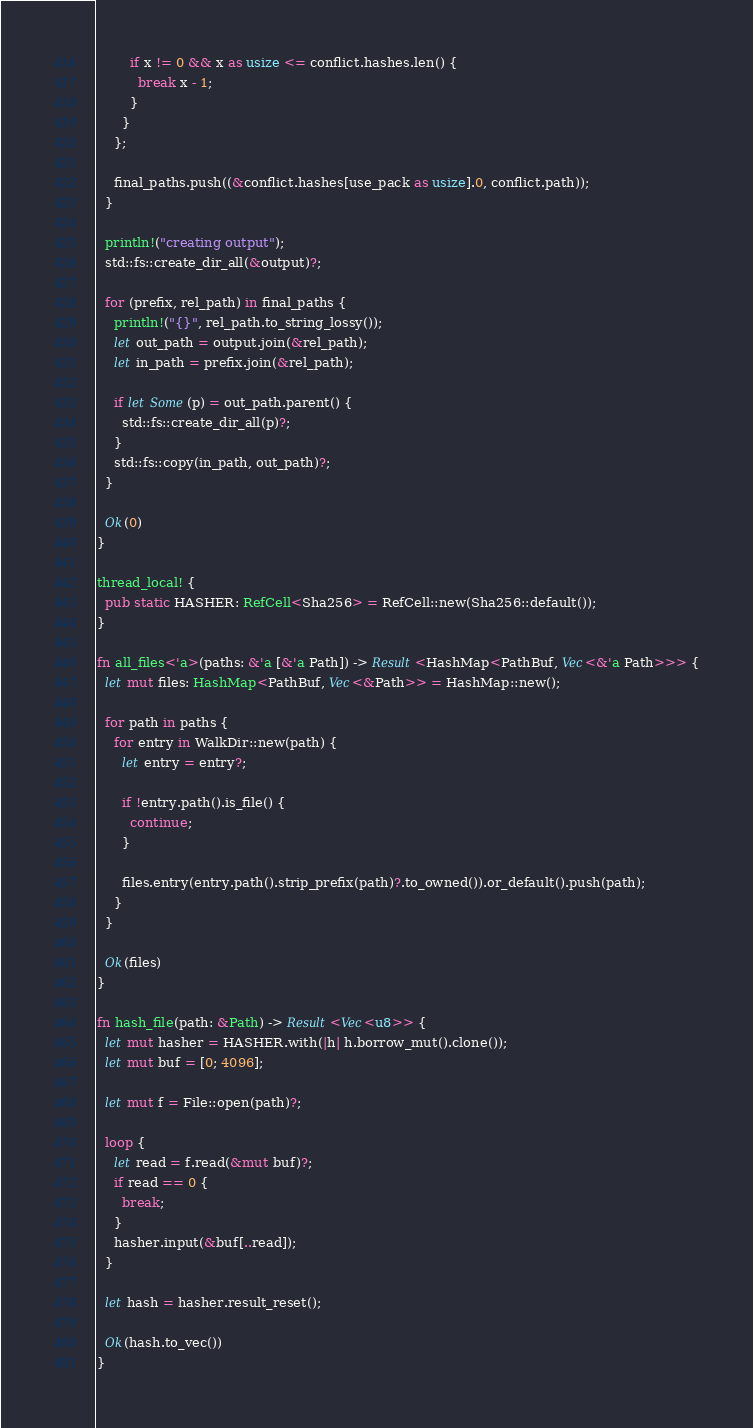<code> <loc_0><loc_0><loc_500><loc_500><_Rust_>        if x != 0 && x as usize <= conflict.hashes.len() {
          break x - 1;
        }
      }
    };

    final_paths.push((&conflict.hashes[use_pack as usize].0, conflict.path));
  }

  println!("creating output");
  std::fs::create_dir_all(&output)?;

  for (prefix, rel_path) in final_paths {
    println!("{}", rel_path.to_string_lossy());
    let out_path = output.join(&rel_path);
    let in_path = prefix.join(&rel_path);

    if let Some(p) = out_path.parent() {
      std::fs::create_dir_all(p)?;
    }
    std::fs::copy(in_path, out_path)?;
  }

  Ok(0)
}

thread_local! {
  pub static HASHER: RefCell<Sha256> = RefCell::new(Sha256::default());
}

fn all_files<'a>(paths: &'a [&'a Path]) -> Result<HashMap<PathBuf, Vec<&'a Path>>> {
  let mut files: HashMap<PathBuf, Vec<&Path>> = HashMap::new();

  for path in paths {
    for entry in WalkDir::new(path) {
      let entry = entry?;

      if !entry.path().is_file() {
        continue;
      }

      files.entry(entry.path().strip_prefix(path)?.to_owned()).or_default().push(path);
    }
  }

  Ok(files)
}

fn hash_file(path: &Path) -> Result<Vec<u8>> {
  let mut hasher = HASHER.with(|h| h.borrow_mut().clone());
  let mut buf = [0; 4096];

  let mut f = File::open(path)?;

  loop {
    let read = f.read(&mut buf)?;
    if read == 0 {
      break;
    }
    hasher.input(&buf[..read]);
  }

  let hash = hasher.result_reset();

  Ok(hash.to_vec())
}
</code> 